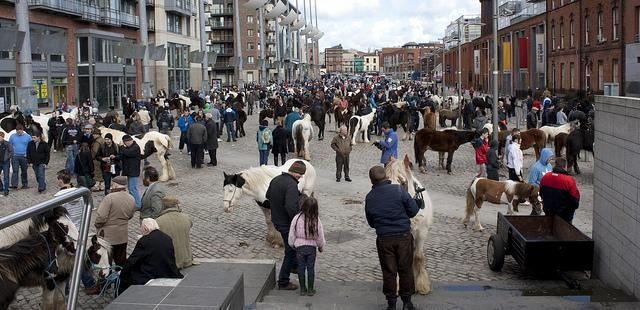What animal are the people checking out? Please explain your reasoning. horses. The other options aren't in the picture. 